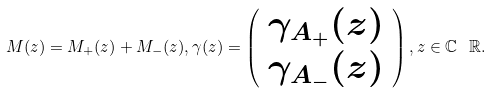<formula> <loc_0><loc_0><loc_500><loc_500>M ( z ) = M _ { + } ( z ) + M _ { - } ( z ) , \gamma ( z ) = \left ( \begin{array} { c } \gamma _ { A _ { + } } ( z ) \\ \gamma _ { A _ { - } } ( z ) \\ \end{array} \right ) , z \in \mathbb { C } \ \mathbb { R } .</formula> 